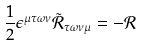Convert formula to latex. <formula><loc_0><loc_0><loc_500><loc_500>\frac { 1 } { 2 } \epsilon ^ { \mu \tau \omega \nu } \tilde { \mathcal { R } } _ { \tau \omega \nu \mu } = - { \mathcal { R } }</formula> 